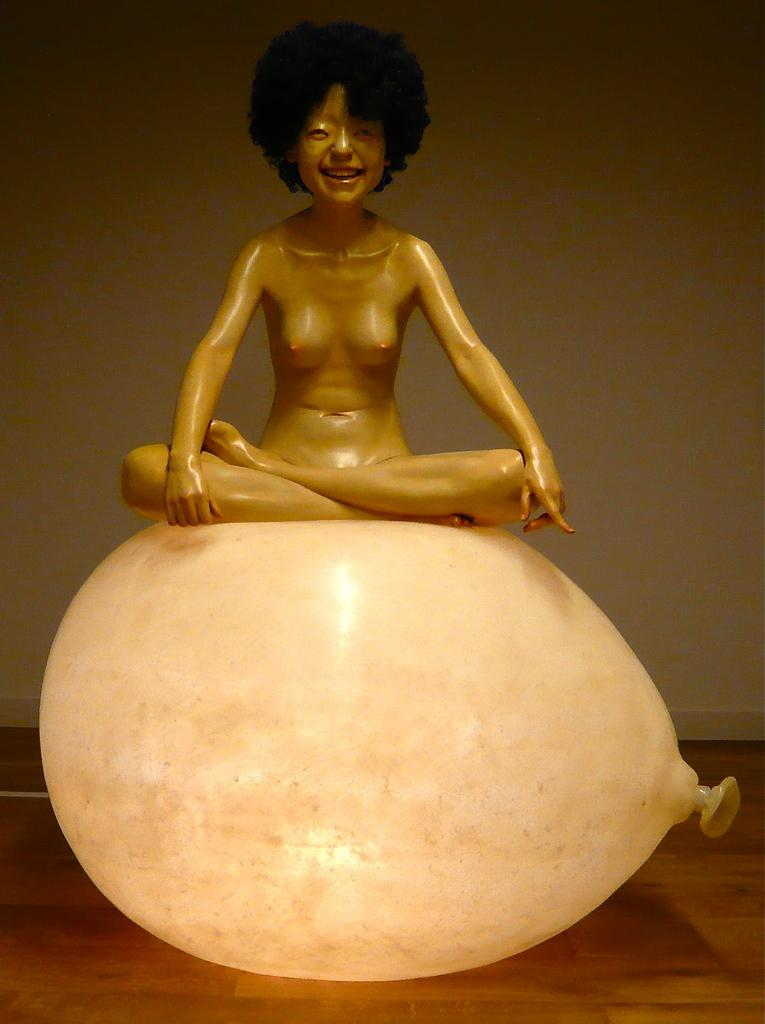What is the main subject in the middle of the image? There is a toy in the middle of the image. How is the toy positioned in the image? The toy is on a balloon. What type of surface is visible at the bottom of the image? There is a floor visible at the bottom of the image. What can be seen in the background of the image? There is a wall in the background of the image. What type of shoes is the toy wearing in the image? The toy does not have shoes, as it is a toy and not a person or an animal. 